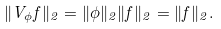<formula> <loc_0><loc_0><loc_500><loc_500>\| V _ { \phi } f \| _ { 2 } = \| \phi \| _ { 2 } \| f \| _ { 2 } = \| f \| _ { 2 } .</formula> 